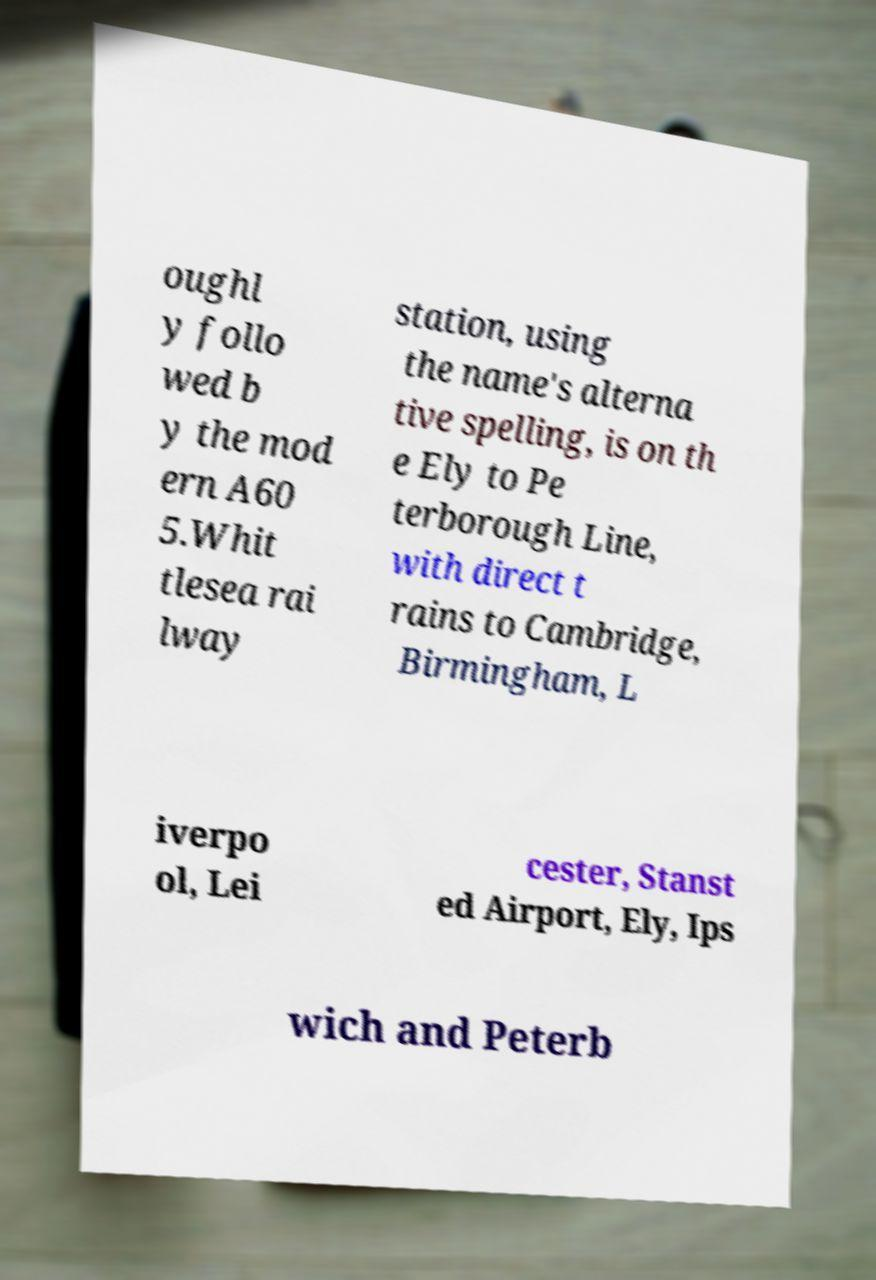Could you extract and type out the text from this image? oughl y follo wed b y the mod ern A60 5.Whit tlesea rai lway station, using the name's alterna tive spelling, is on th e Ely to Pe terborough Line, with direct t rains to Cambridge, Birmingham, L iverpo ol, Lei cester, Stanst ed Airport, Ely, Ips wich and Peterb 